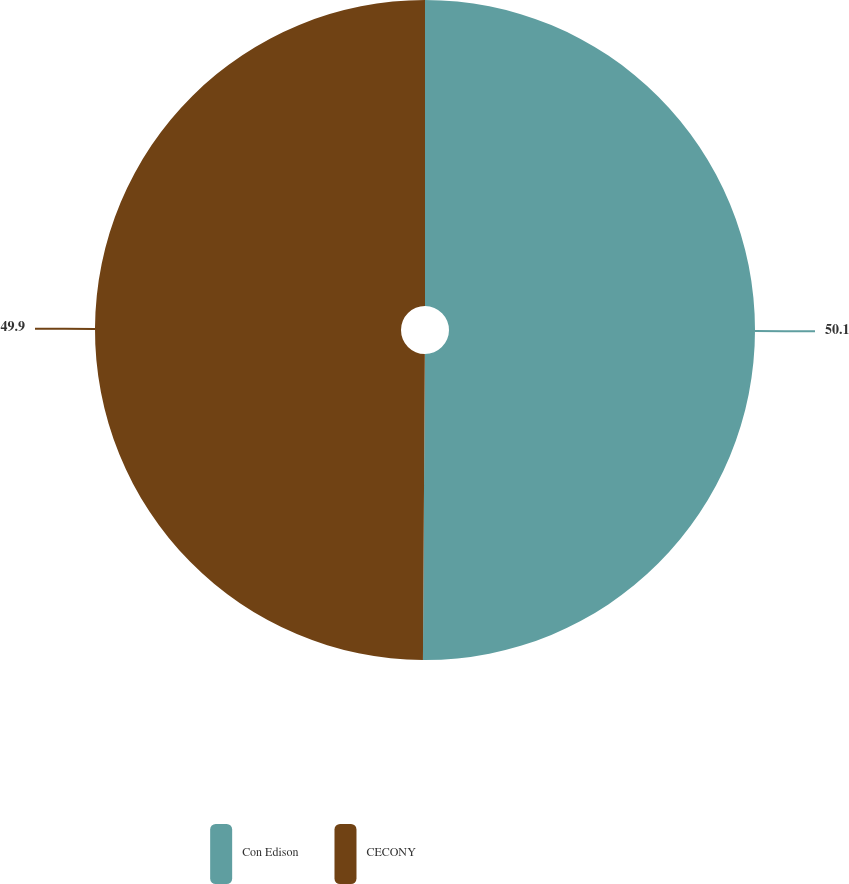<chart> <loc_0><loc_0><loc_500><loc_500><pie_chart><fcel>Con Edison<fcel>CECONY<nl><fcel>50.1%<fcel>49.9%<nl></chart> 